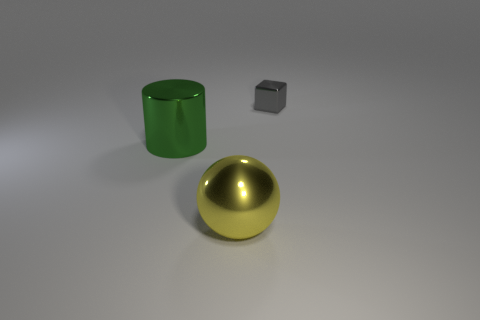Add 2 big purple matte balls. How many objects exist? 5 Subtract all cylinders. How many objects are left? 2 Subtract 0 red blocks. How many objects are left? 3 Subtract all big yellow metal things. Subtract all yellow balls. How many objects are left? 1 Add 2 small gray shiny blocks. How many small gray shiny blocks are left? 3 Add 1 large metallic cylinders. How many large metallic cylinders exist? 2 